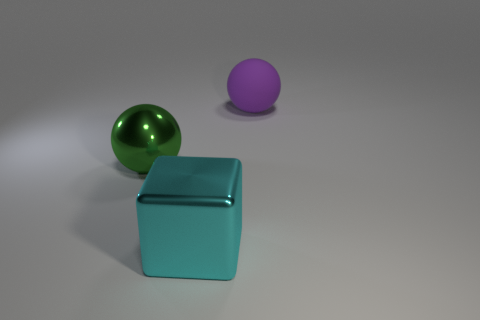There is a large purple rubber object; is its shape the same as the big shiny thing to the left of the big cyan thing?
Offer a terse response. Yes. The other big object that is made of the same material as the cyan object is what color?
Keep it short and to the point. Green. The rubber ball is what color?
Ensure brevity in your answer.  Purple. Do the block and the ball in front of the rubber object have the same material?
Your answer should be very brief. Yes. What number of large things are right of the green metal thing and behind the big cube?
Your response must be concise. 1. There is another cyan object that is the same size as the matte thing; what shape is it?
Your answer should be very brief. Cube. There is a big thing that is behind the large ball left of the big rubber thing; are there any purple rubber things right of it?
Ensure brevity in your answer.  No. What size is the sphere that is to the left of the big thing on the right side of the cyan object?
Ensure brevity in your answer.  Large. What number of objects are spheres in front of the large purple matte sphere or large purple things?
Your response must be concise. 2. Is there a metallic object of the same size as the cyan block?
Offer a very short reply. Yes. 